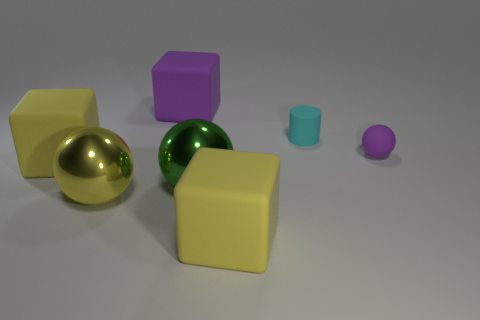There is a object that is on the right side of the green metal sphere and on the left side of the cyan object; what is its size?
Make the answer very short. Large. Is there anything else that is the same color as the tiny matte sphere?
Make the answer very short. Yes. What is the shape of the big purple thing that is made of the same material as the cyan cylinder?
Make the answer very short. Cube. Do the big yellow metal thing and the purple object left of the cyan matte cylinder have the same shape?
Ensure brevity in your answer.  No. What material is the purple ball behind the yellow matte block that is behind the big green sphere made of?
Make the answer very short. Rubber. Are there an equal number of large rubber blocks that are to the right of the rubber ball and rubber cylinders?
Ensure brevity in your answer.  No. Is there any other thing that has the same material as the large purple thing?
Offer a very short reply. Yes. There is a small matte object left of the small sphere; is it the same color as the shiny thing to the left of the green metal object?
Ensure brevity in your answer.  No. How many large yellow cubes are to the left of the big green sphere and on the right side of the yellow metal thing?
Provide a short and direct response. 0. How many other objects are there of the same shape as the small cyan object?
Offer a very short reply. 0. 